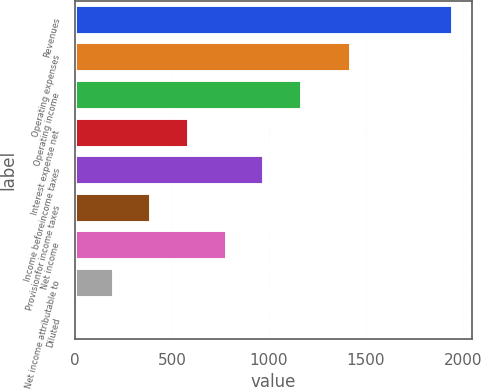<chart> <loc_0><loc_0><loc_500><loc_500><bar_chart><fcel>Revenues<fcel>Operating expenses<fcel>Operating income<fcel>Interest expense net<fcel>Income beforeincome taxes<fcel>Provisionfor income taxes<fcel>Net income<fcel>Net income attributable to<fcel>Diluted<nl><fcel>1947.2<fcel>1425.2<fcel>1170.47<fcel>587.93<fcel>976.29<fcel>393.75<fcel>782.11<fcel>199.57<fcel>5.39<nl></chart> 